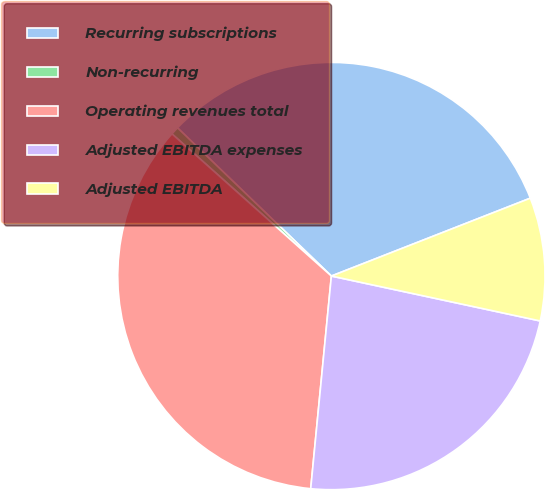Convert chart. <chart><loc_0><loc_0><loc_500><loc_500><pie_chart><fcel>Recurring subscriptions<fcel>Non-recurring<fcel>Operating revenues total<fcel>Adjusted EBITDA expenses<fcel>Adjusted EBITDA<nl><fcel>31.86%<fcel>0.61%<fcel>35.05%<fcel>23.17%<fcel>9.31%<nl></chart> 